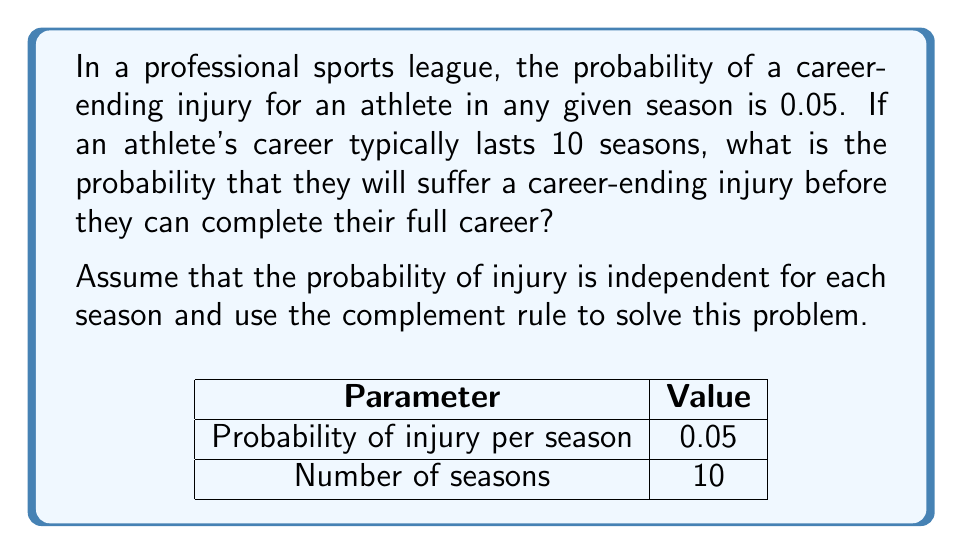What is the answer to this math problem? Let's approach this step-by-step:

1) First, let's define our events:
   Let A be the event "athlete suffers a career-ending injury before completing 10 seasons"
   Let B be the event "athlete completes 10 seasons without a career-ending injury"

2) We're looking for P(A), but it's easier to calculate P(B) and then use the complement rule:
   P(A) = 1 - P(B)

3) For an athlete to complete 10 seasons, they must not suffer a career-ending injury in any of the 10 seasons. The probability of not suffering an injury in one season is:
   1 - 0.05 = 0.95

4) Since the events are independent for each season, we can multiply the probabilities:
   P(B) = (0.95)^10

5) Now we can calculate:
   P(B) = (0.95)^10 ≈ 0.5987

6) Using the complement rule:
   P(A) = 1 - P(B) = 1 - 0.5987 ≈ 0.4013

7) Therefore, the probability of suffering a career-ending injury before completing 10 seasons is approximately 0.4013 or 40.13%.

This high probability might explain why some athletes fail to achieve their full potential, potentially fueling resentment in those who didn't make it professionally.
Answer: $$1 - (0.95)^{10} \approx 0.4013$$ or 40.13% 